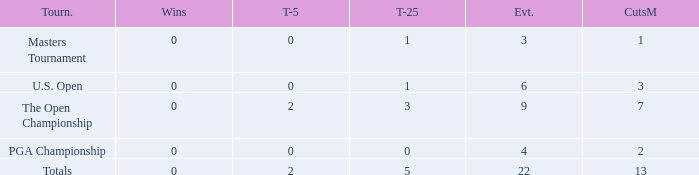What is the fewest wins for Thomas in events he had entered exactly 9 times? 0.0. 